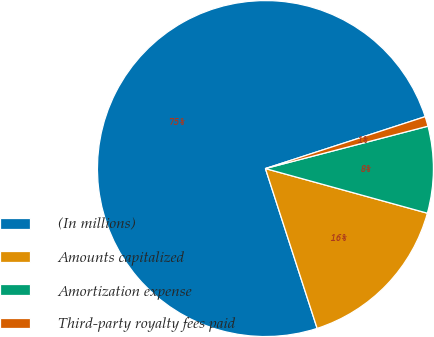Convert chart. <chart><loc_0><loc_0><loc_500><loc_500><pie_chart><fcel>(In millions)<fcel>Amounts capitalized<fcel>Amortization expense<fcel>Third-party royalty fees paid<nl><fcel>74.98%<fcel>15.74%<fcel>8.34%<fcel>0.94%<nl></chart> 